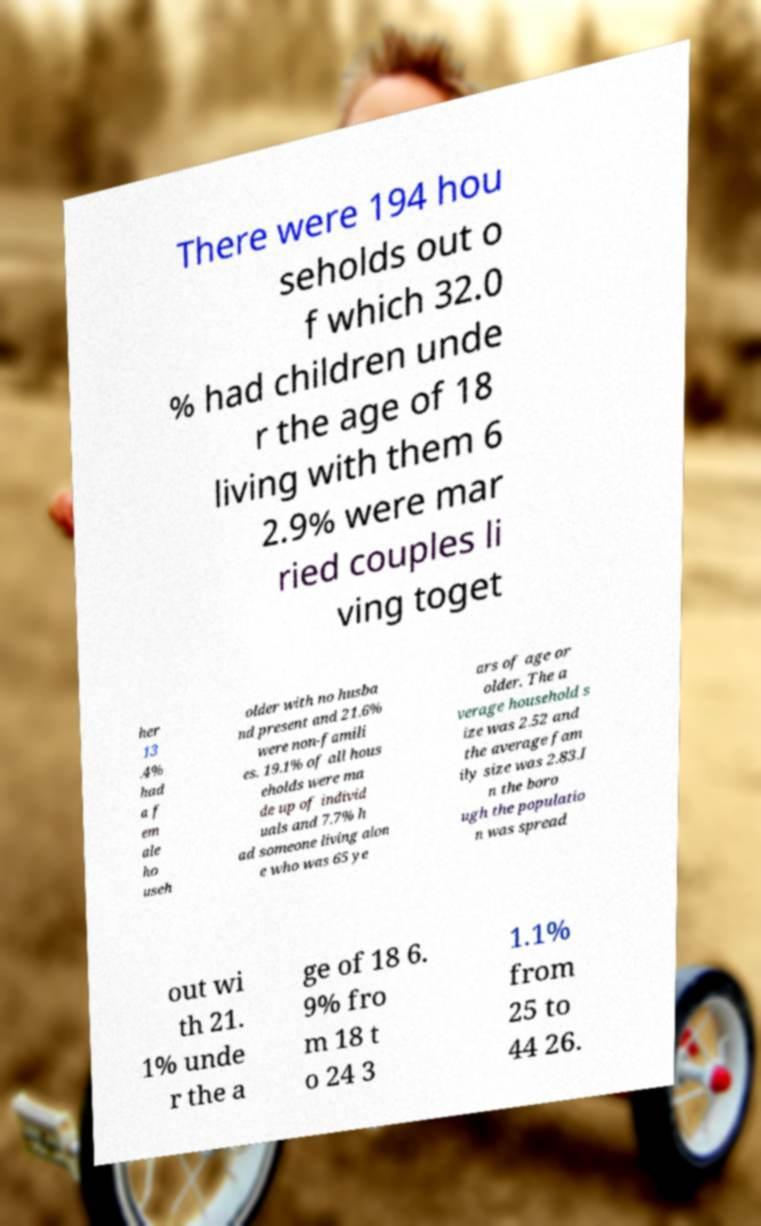Can you read and provide the text displayed in the image?This photo seems to have some interesting text. Can you extract and type it out for me? There were 194 hou seholds out o f which 32.0 % had children unde r the age of 18 living with them 6 2.9% were mar ried couples li ving toget her 13 .4% had a f em ale ho useh older with no husba nd present and 21.6% were non-famili es. 19.1% of all hous eholds were ma de up of individ uals and 7.7% h ad someone living alon e who was 65 ye ars of age or older. The a verage household s ize was 2.52 and the average fam ily size was 2.83.I n the boro ugh the populatio n was spread out wi th 21. 1% unde r the a ge of 18 6. 9% fro m 18 t o 24 3 1.1% from 25 to 44 26. 